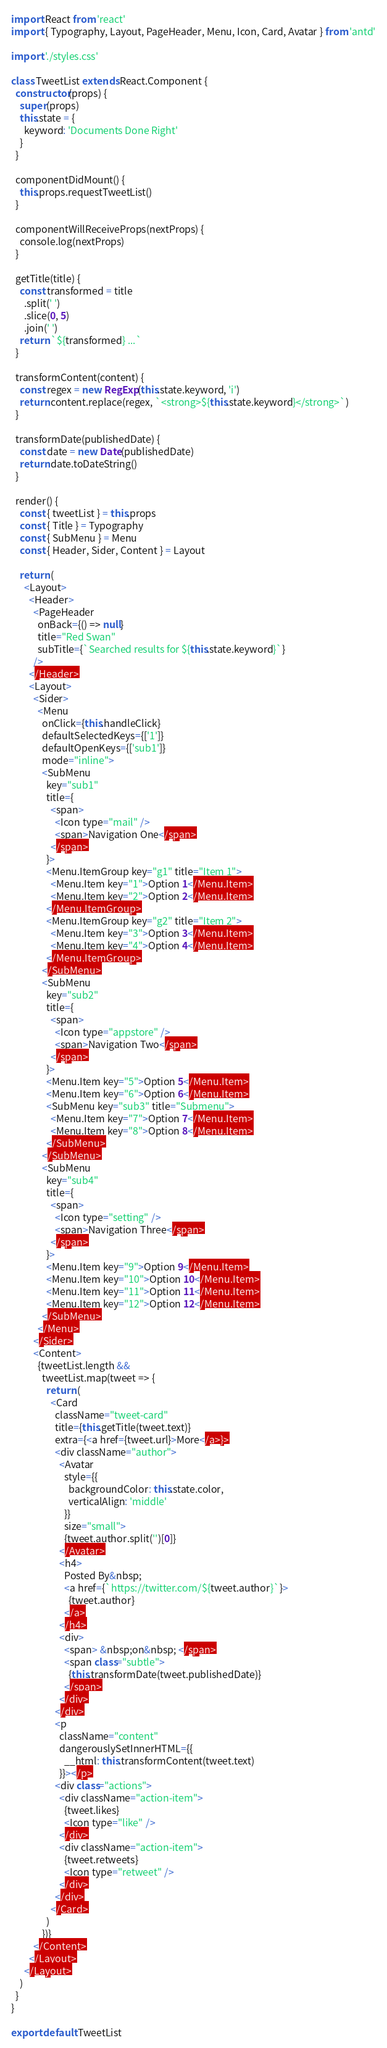<code> <loc_0><loc_0><loc_500><loc_500><_JavaScript_>import React from 'react'
import { Typography, Layout, PageHeader, Menu, Icon, Card, Avatar } from 'antd'

import './styles.css'

class TweetList extends React.Component {
  constructor(props) {
    super(props)
    this.state = {
      keyword: 'Documents Done Right'
    }
  }

  componentDidMount() {
    this.props.requestTweetList()
  }

  componentWillReceiveProps(nextProps) {
    console.log(nextProps)
  }

  getTitle(title) {
    const transformed = title
      .split(' ')
      .slice(0, 5)
      .join(' ')
    return `${transformed} ...`
  }

  transformContent(content) {
    const regex = new RegExp(this.state.keyword, 'i')
    return content.replace(regex, `<strong>${this.state.keyword}</strong>`)
  }

  transformDate(publishedDate) {
    const date = new Date(publishedDate)
    return date.toDateString()
  }

  render() {
    const { tweetList } = this.props
    const { Title } = Typography
    const { SubMenu } = Menu
    const { Header, Sider, Content } = Layout

    return (
      <Layout>
        <Header>
          <PageHeader
            onBack={() => null}
            title="Red Swan"
            subTitle={`Searched results for ${this.state.keyword}`}
          />
        </Header>
        <Layout>
          <Sider>
            <Menu
              onClick={this.handleClick}
              defaultSelectedKeys={['1']}
              defaultOpenKeys={['sub1']}
              mode="inline">
              <SubMenu
                key="sub1"
                title={
                  <span>
                    <Icon type="mail" />
                    <span>Navigation One</span>
                  </span>
                }>
                <Menu.ItemGroup key="g1" title="Item 1">
                  <Menu.Item key="1">Option 1</Menu.Item>
                  <Menu.Item key="2">Option 2</Menu.Item>
                </Menu.ItemGroup>
                <Menu.ItemGroup key="g2" title="Item 2">
                  <Menu.Item key="3">Option 3</Menu.Item>
                  <Menu.Item key="4">Option 4</Menu.Item>
                </Menu.ItemGroup>
              </SubMenu>
              <SubMenu
                key="sub2"
                title={
                  <span>
                    <Icon type="appstore" />
                    <span>Navigation Two</span>
                  </span>
                }>
                <Menu.Item key="5">Option 5</Menu.Item>
                <Menu.Item key="6">Option 6</Menu.Item>
                <SubMenu key="sub3" title="Submenu">
                  <Menu.Item key="7">Option 7</Menu.Item>
                  <Menu.Item key="8">Option 8</Menu.Item>
                </SubMenu>
              </SubMenu>
              <SubMenu
                key="sub4"
                title={
                  <span>
                    <Icon type="setting" />
                    <span>Navigation Three</span>
                  </span>
                }>
                <Menu.Item key="9">Option 9</Menu.Item>
                <Menu.Item key="10">Option 10</Menu.Item>
                <Menu.Item key="11">Option 11</Menu.Item>
                <Menu.Item key="12">Option 12</Menu.Item>
              </SubMenu>
            </Menu>
          </Sider>
          <Content>
            {tweetList.length &&
              tweetList.map(tweet => {
                return (
                  <Card
                    className="tweet-card"
                    title={this.getTitle(tweet.text)}
                    extra={<a href={tweet.url}>More</a>}>
                    <div className="author">
                      <Avatar
                        style={{
                          backgroundColor: this.state.color,
                          verticalAlign: 'middle'
                        }}
                        size="small">
                        {tweet.author.split('')[0]}
                      </Avatar>
                      <h4>
                        Posted By&nbsp;
                        <a href={`https://twitter.com/${tweet.author}`}>
                          {tweet.author}
                        </a>
                      </h4>
                      <div>
                        <span> &nbsp;on&nbsp; </span>
                        <span class="subtle">
                          {this.transformDate(tweet.publishedDate)}
                        </span>
                      </div>
                    </div>
                    <p
                      className="content"
                      dangerouslySetInnerHTML={{
                        __html: this.transformContent(tweet.text)
                      }}></p>
                    <div class="actions">
                      <div className="action-item">
                        {tweet.likes}
                        <Icon type="like" />
                      </div>
                      <div className="action-item">
                        {tweet.retweets}
                        <Icon type="retweet" />
                      </div>
                    </div>
                  </Card>
                )
              })}
          </Content>
        </Layout>
      </Layout>
    )
  }
}

export default TweetList
</code> 